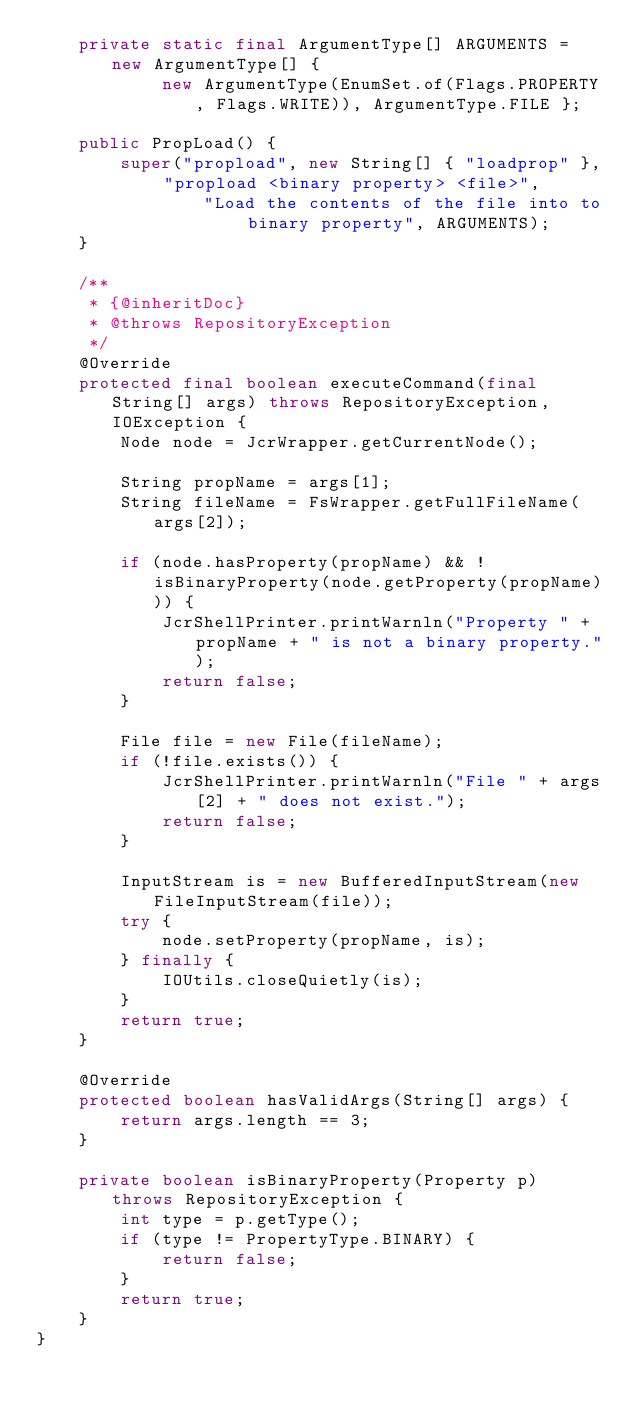Convert code to text. <code><loc_0><loc_0><loc_500><loc_500><_Java_>    private static final ArgumentType[] ARGUMENTS = new ArgumentType[] {
            new ArgumentType(EnumSet.of(Flags.PROPERTY, Flags.WRITE)), ArgumentType.FILE };

    public PropLoad() {
        super("propload", new String[] { "loadprop" }, "propload <binary property> <file>",
                "Load the contents of the file into to binary property", ARGUMENTS);
    }

    /**
     * {@inheritDoc}
     * @throws RepositoryException 
     */
    @Override
    protected final boolean executeCommand(final String[] args) throws RepositoryException, IOException {
        Node node = JcrWrapper.getCurrentNode();

        String propName = args[1];
        String fileName = FsWrapper.getFullFileName(args[2]);

        if (node.hasProperty(propName) && !isBinaryProperty(node.getProperty(propName))) {
            JcrShellPrinter.printWarnln("Property " + propName + " is not a binary property.");
            return false;
        }

        File file = new File(fileName);
        if (!file.exists()) {
            JcrShellPrinter.printWarnln("File " + args[2] + " does not exist.");
            return false;
        }

        InputStream is = new BufferedInputStream(new FileInputStream(file)); 
        try {
            node.setProperty(propName, is);
        } finally {
            IOUtils.closeQuietly(is);
        }
        return true;
    }

    @Override
    protected boolean hasValidArgs(String[] args) {
        return args.length == 3;
    }

    private boolean isBinaryProperty(Property p) throws RepositoryException {
        int type = p.getType();
        if (type != PropertyType.BINARY) {
            return false;
        }
        return true;
    }
}
</code> 